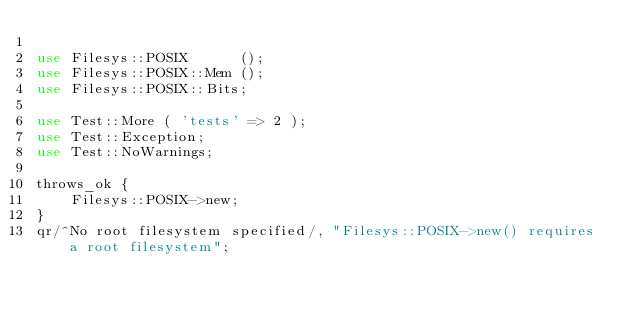Convert code to text. <code><loc_0><loc_0><loc_500><loc_500><_Perl_>
use Filesys::POSIX      ();
use Filesys::POSIX::Mem ();
use Filesys::POSIX::Bits;

use Test::More ( 'tests' => 2 );
use Test::Exception;
use Test::NoWarnings;

throws_ok {
    Filesys::POSIX->new;
}
qr/^No root filesystem specified/, "Filesys::POSIX->new() requires a root filesystem";
</code> 